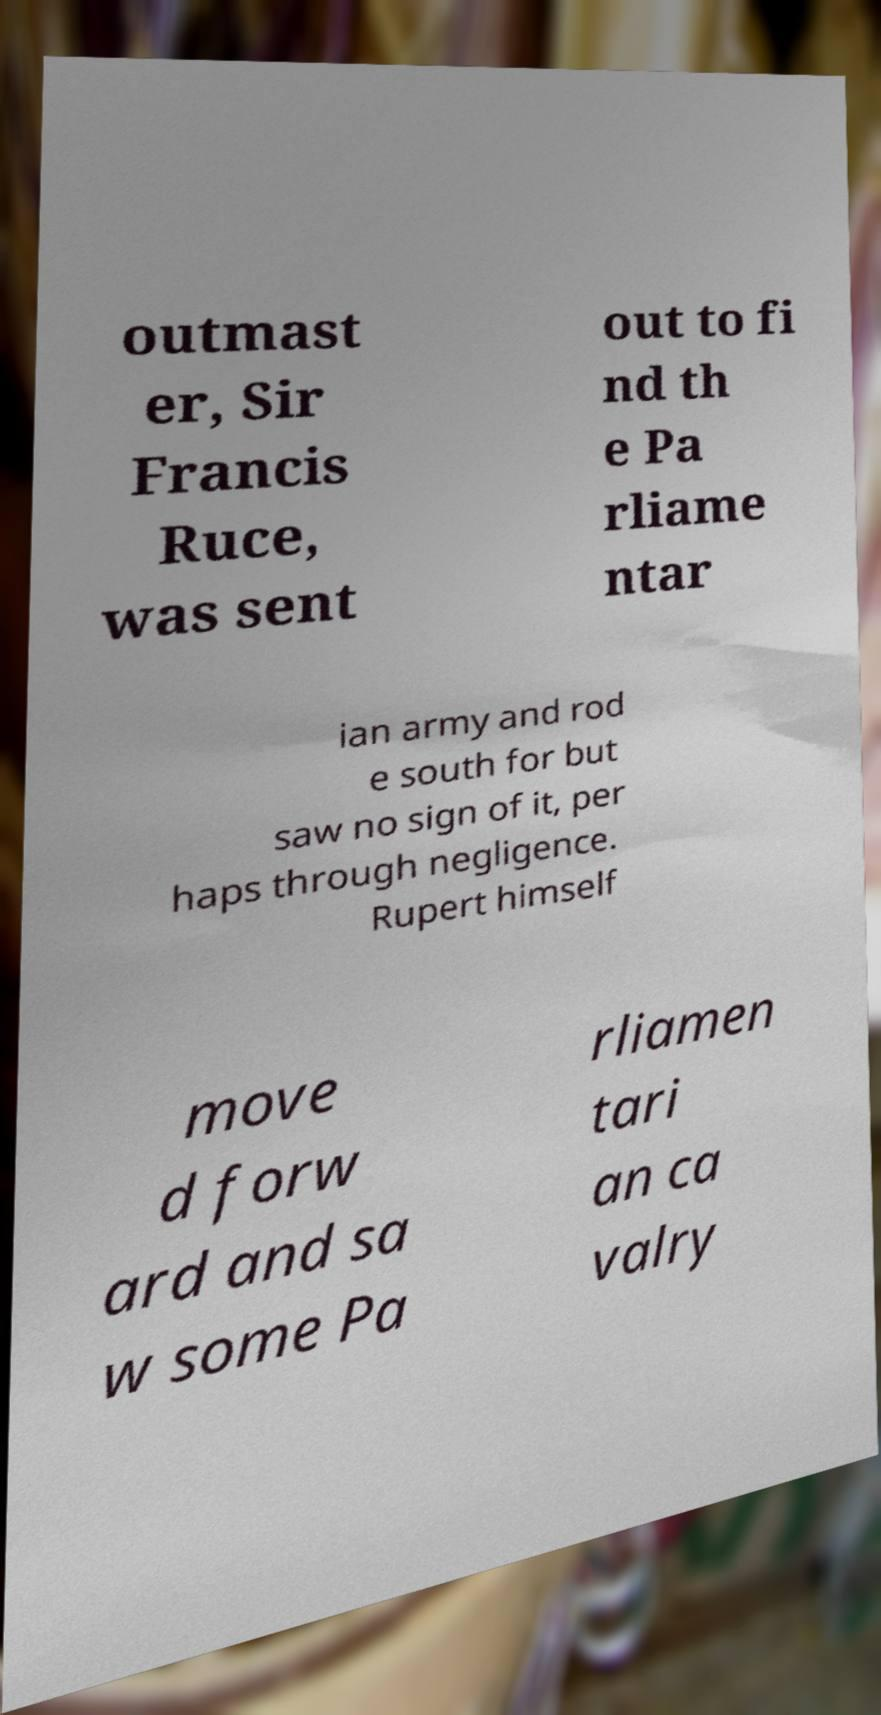Can you read and provide the text displayed in the image?This photo seems to have some interesting text. Can you extract and type it out for me? outmast er, Sir Francis Ruce, was sent out to fi nd th e Pa rliame ntar ian army and rod e south for but saw no sign of it, per haps through negligence. Rupert himself move d forw ard and sa w some Pa rliamen tari an ca valry 